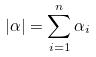<formula> <loc_0><loc_0><loc_500><loc_500>| \alpha | = \sum _ { i = 1 } ^ { n } \alpha _ { i }</formula> 